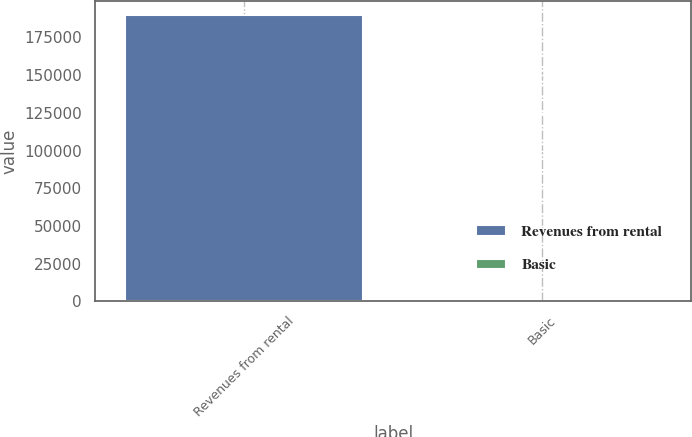Convert chart to OTSL. <chart><loc_0><loc_0><loc_500><loc_500><bar_chart><fcel>Revenues from rental<fcel>Basic<nl><fcel>189951<fcel>0.38<nl></chart> 